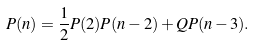<formula> <loc_0><loc_0><loc_500><loc_500>P ( n ) = \frac { 1 } { 2 } P ( 2 ) P ( n - 2 ) + Q P ( n - 3 ) .</formula> 